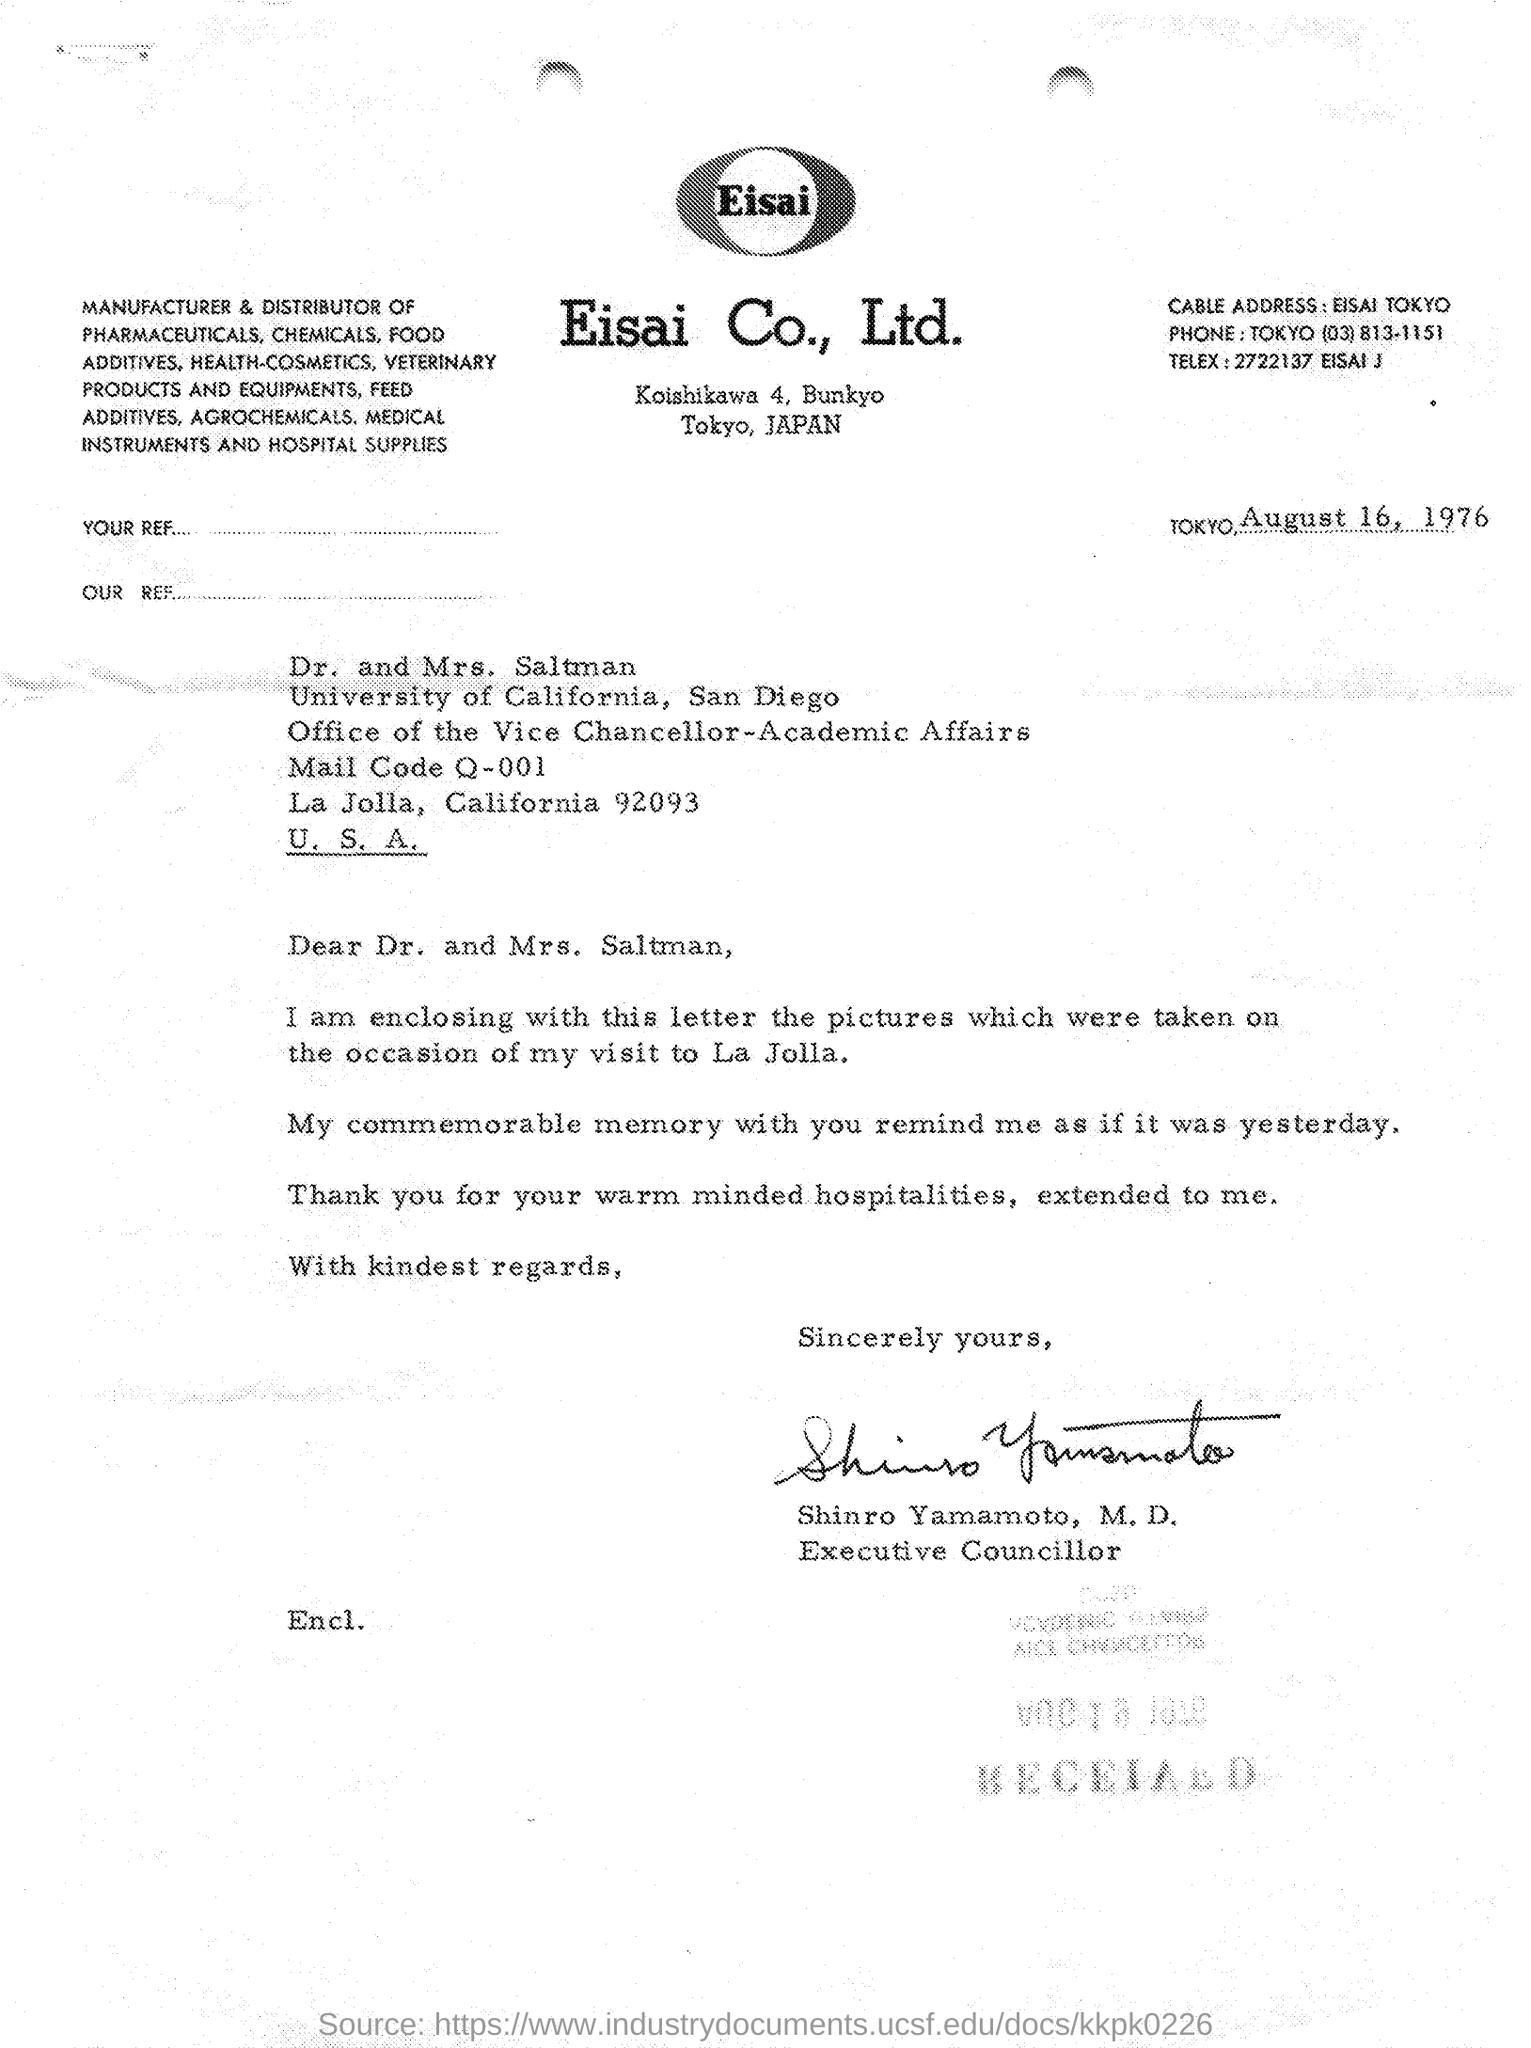Draw attention to some important aspects in this diagram. The cable address mentioned in the given letter is "EISAI TOKYO..". The date mentioned in the given letter is August 16, 1976. The signature at the end of the letter belonged to Shinro Yamamoto. Shinro Yamamoto holds the designation of Executive Councillor. The phone number mentioned in the given letter is (03) 813-1151, which is located in Tokyo. 